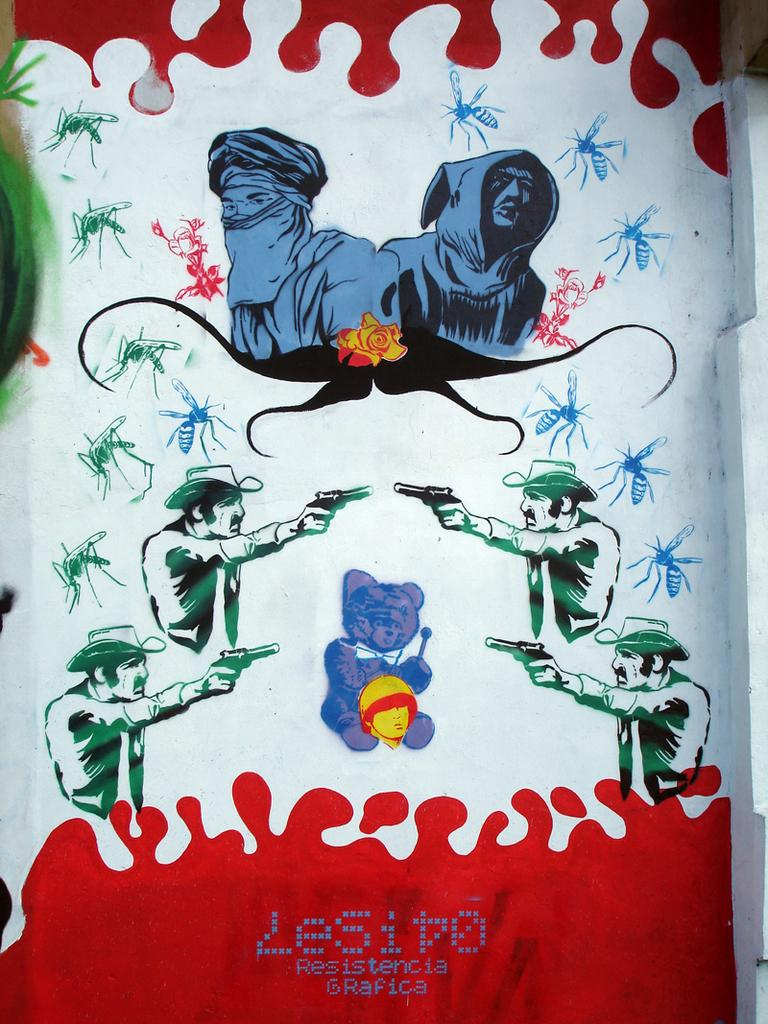What is the main subject of the image? The main subject of the image is a painting. What types of subjects are depicted in the painting? The painting contains people and insects, as well as other objects. Is there any text associated with the image? Yes, there is text at the bottom of the image. How does the painting help with digestion? The painting does not have any direct impact on digestion, as it is a visual work of art and not a digestive aid. 